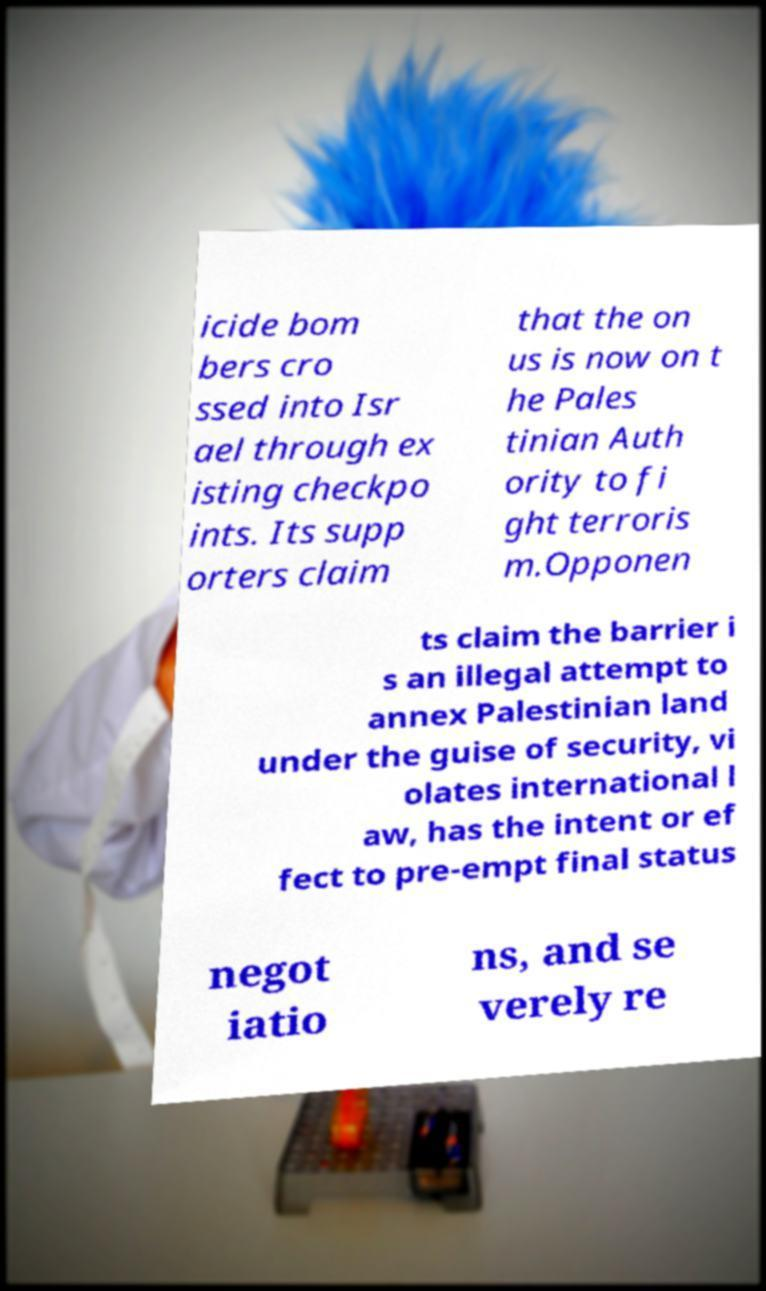Please identify and transcribe the text found in this image. icide bom bers cro ssed into Isr ael through ex isting checkpo ints. Its supp orters claim that the on us is now on t he Pales tinian Auth ority to fi ght terroris m.Opponen ts claim the barrier i s an illegal attempt to annex Palestinian land under the guise of security, vi olates international l aw, has the intent or ef fect to pre-empt final status negot iatio ns, and se verely re 